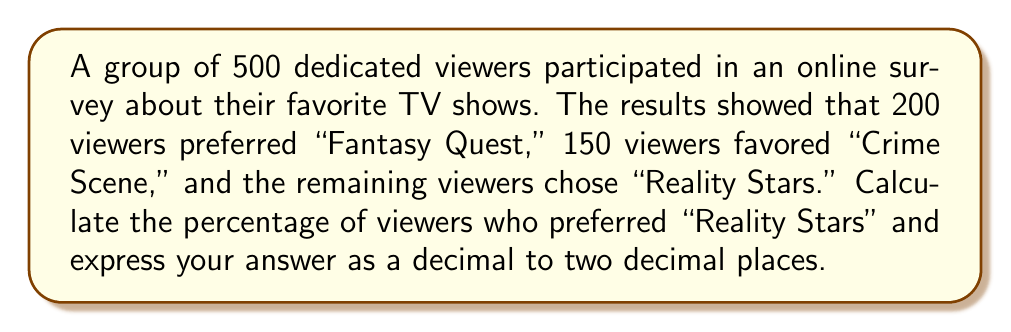Solve this math problem. To solve this problem, we'll follow these steps:

1. Find the number of viewers who preferred "Reality Stars":
   - Total viewers: 500
   - Viewers preferring "Fantasy Quest": 200
   - Viewers preferring "Crime Scene": 150
   - Viewers preferring "Reality Stars": $500 - 200 - 150 = 150$

2. Calculate the percentage of viewers who preferred "Reality Stars":
   - Percentage = (Number of viewers preferring "Reality Stars" ÷ Total number of viewers) × 100
   - Percentage = $\frac{150}{500} \times 100$

3. Simplify the fraction:
   - $\frac{150}{500} = \frac{3}{10} = 0.3$

4. Calculate the final percentage:
   - $0.3 \times 100 = 30$

Therefore, 30% of viewers preferred "Reality Stars."

5. Express the answer as a decimal to two decimal places:
   - 30% = 0.30
Answer: $0.30$ 